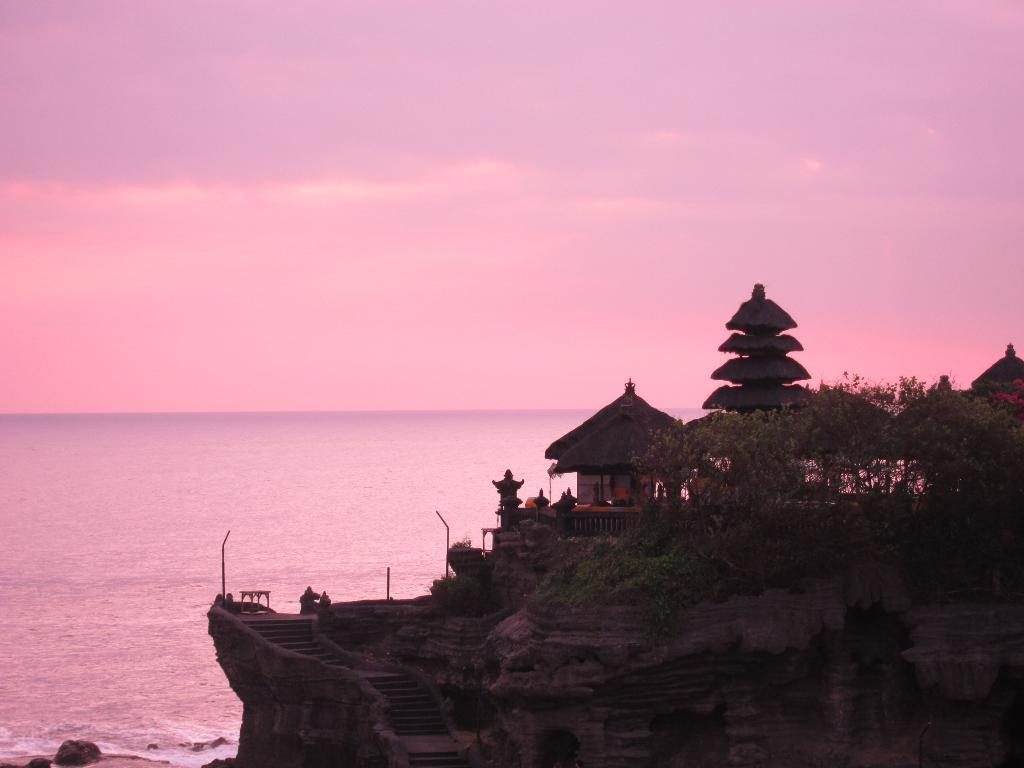Where was the image taken? The image was clicked near the ocean. What can be seen to the right of the image? There is a building to the right of the image. What is located near the building? There are trees near the building. What architectural feature is present in the middle of the image? There are steps in the middle of the image. What natural feature is visible to the left of the image? The ocean is visible to the left of the image. What is visible at the top of the image? The sky is visible at the top of the image. What grade of cheese is being served at the beach in the image? There is no cheese present in the image, and it is not a scene of a meal or gathering. 